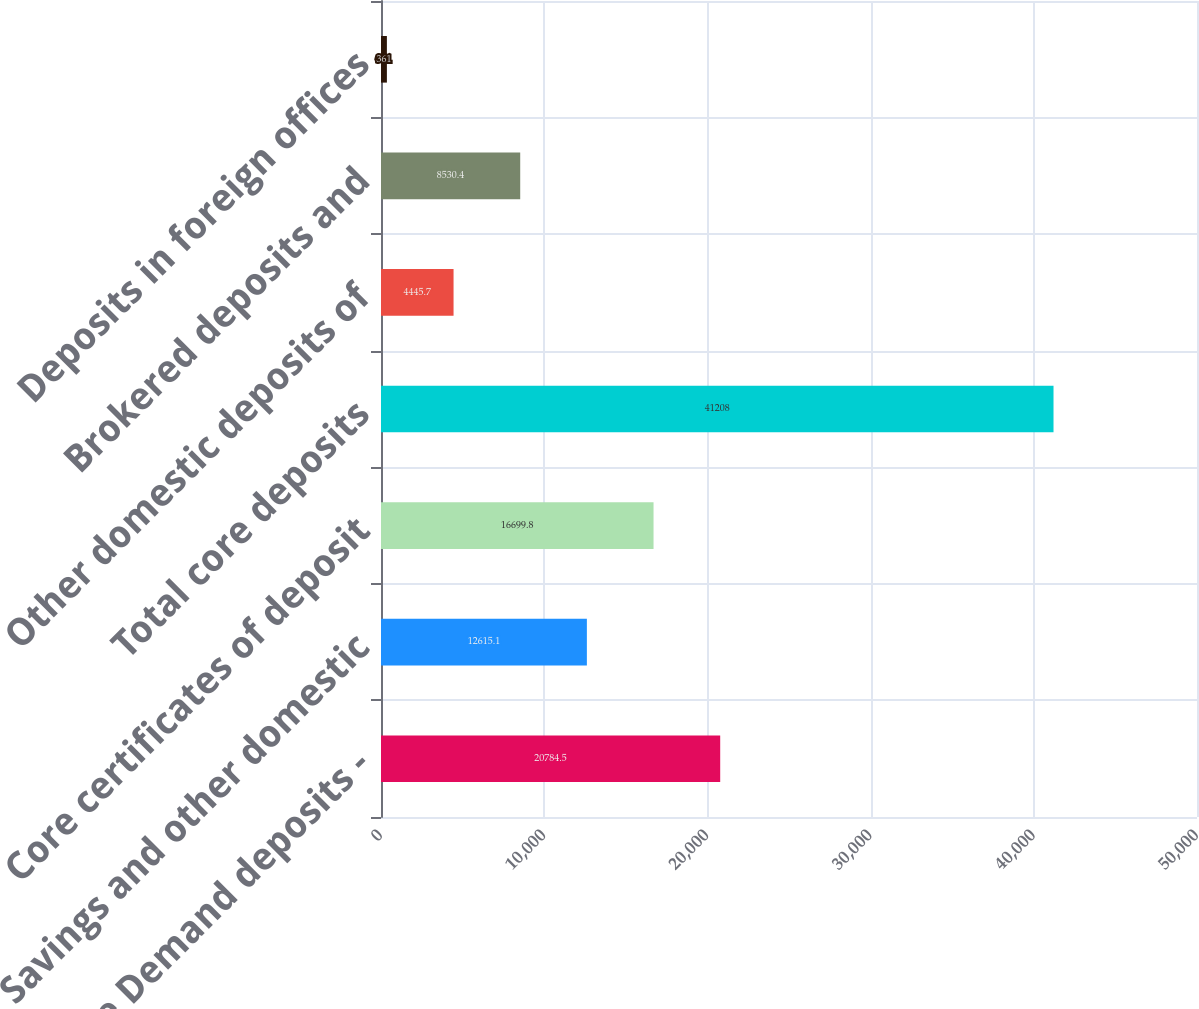Convert chart. <chart><loc_0><loc_0><loc_500><loc_500><bar_chart><fcel>By Type Demand deposits -<fcel>Savings and other domestic<fcel>Core certificates of deposit<fcel>Total core deposits<fcel>Other domestic deposits of<fcel>Brokered deposits and<fcel>Deposits in foreign offices<nl><fcel>20784.5<fcel>12615.1<fcel>16699.8<fcel>41208<fcel>4445.7<fcel>8530.4<fcel>361<nl></chart> 